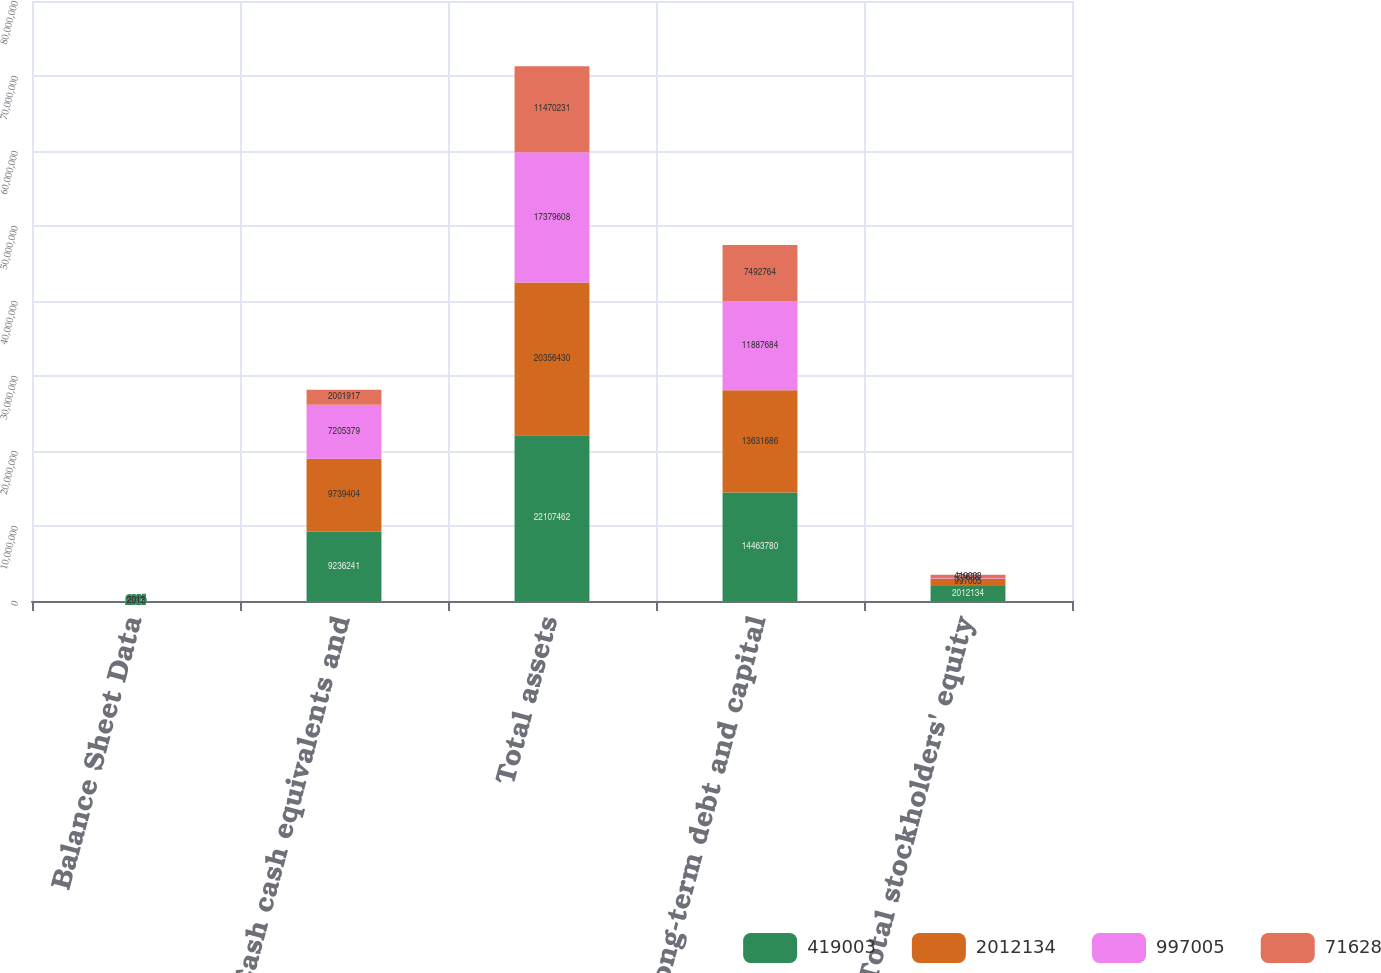Convert chart. <chart><loc_0><loc_0><loc_500><loc_500><stacked_bar_chart><ecel><fcel>Balance Sheet Data<fcel>Cash cash equivalents and<fcel>Total assets<fcel>Long-term debt and capital<fcel>Total stockholders' equity<nl><fcel>419003<fcel>2014<fcel>9.23624e+06<fcel>2.21075e+07<fcel>1.44638e+07<fcel>2.01213e+06<nl><fcel>2.01213e+06<fcel>2013<fcel>9.7394e+06<fcel>2.03564e+07<fcel>1.36317e+07<fcel>997005<nl><fcel>997005<fcel>2012<fcel>7.20538e+06<fcel>1.73796e+07<fcel>1.18877e+07<fcel>71628<nl><fcel>71628<fcel>2011<fcel>2.00192e+06<fcel>1.14702e+07<fcel>7.49276e+06<fcel>419003<nl></chart> 